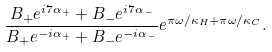Convert formula to latex. <formula><loc_0><loc_0><loc_500><loc_500>\frac { B _ { + } e ^ { i 7 \alpha _ { + } } + B _ { - } e ^ { i 7 \alpha _ { - } } } { B _ { + } e ^ { - i \alpha _ { + } } + B _ { - } e ^ { - i \alpha _ { - } } } e ^ { \pi \omega / \kappa _ { H } + \pi \omega / \kappa _ { C } } .</formula> 